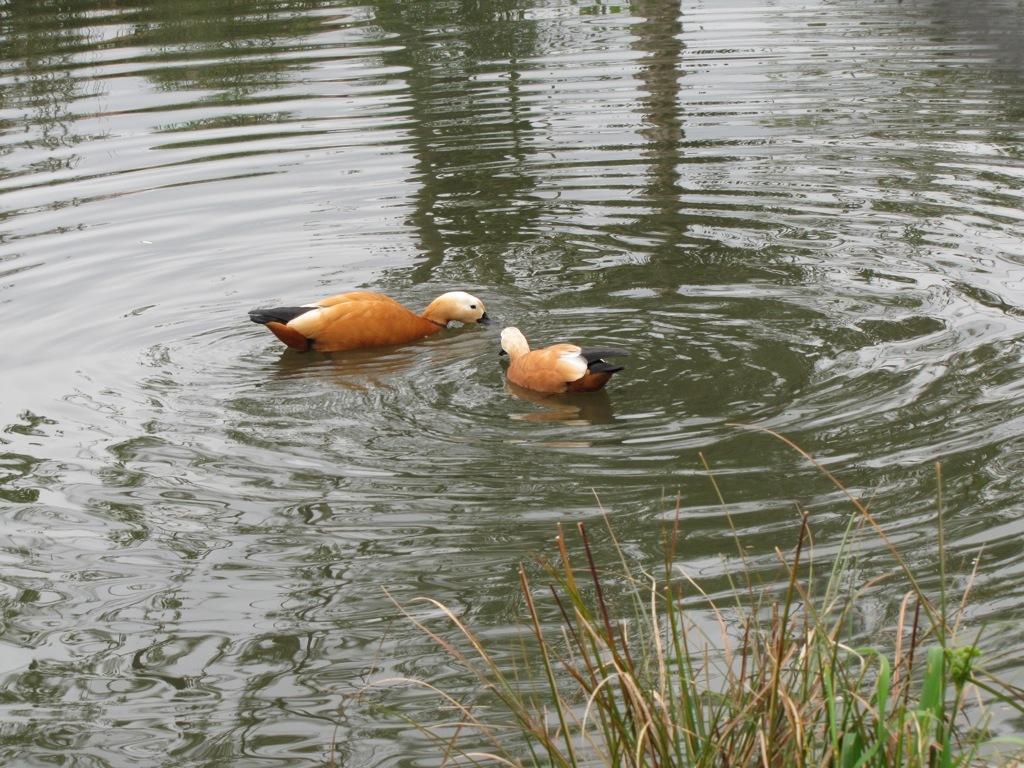Can you describe this image briefly? This picture is clicked outside the city. In the foreground we can see the grass. In the center we can see the two birds seems to be the ducks in the water body and we can see the ripples in the water body. 